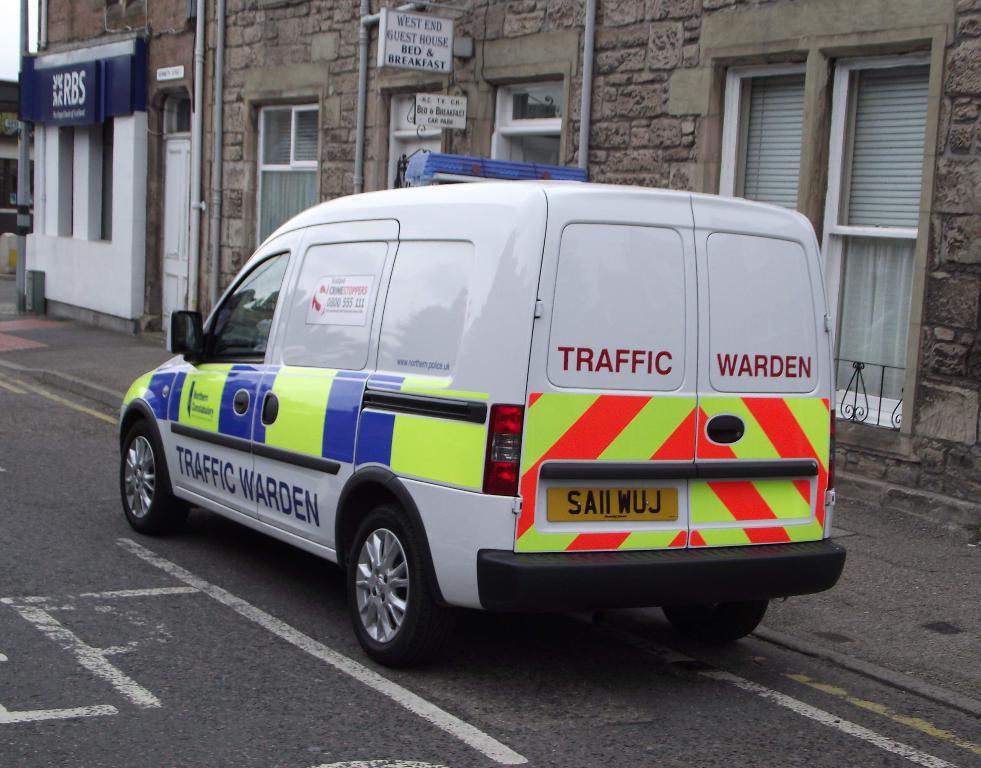Is that a traffic cop?
Ensure brevity in your answer.  Yes. What is the license plate number?
Offer a terse response. Saii wuj. 